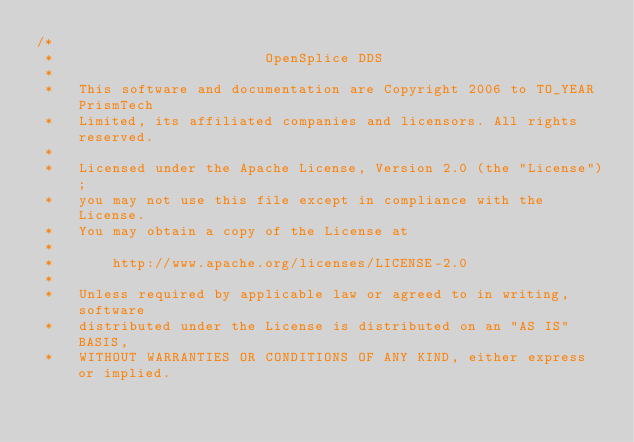<code> <loc_0><loc_0><loc_500><loc_500><_C_>/*
 *                         OpenSplice DDS
 *
 *   This software and documentation are Copyright 2006 to TO_YEAR PrismTech
 *   Limited, its affiliated companies and licensors. All rights reserved.
 *
 *   Licensed under the Apache License, Version 2.0 (the "License");
 *   you may not use this file except in compliance with the License.
 *   You may obtain a copy of the License at
 *
 *       http://www.apache.org/licenses/LICENSE-2.0
 *
 *   Unless required by applicable law or agreed to in writing, software
 *   distributed under the License is distributed on an "AS IS" BASIS,
 *   WITHOUT WARRANTIES OR CONDITIONS OF ANY KIND, either express or implied.</code> 